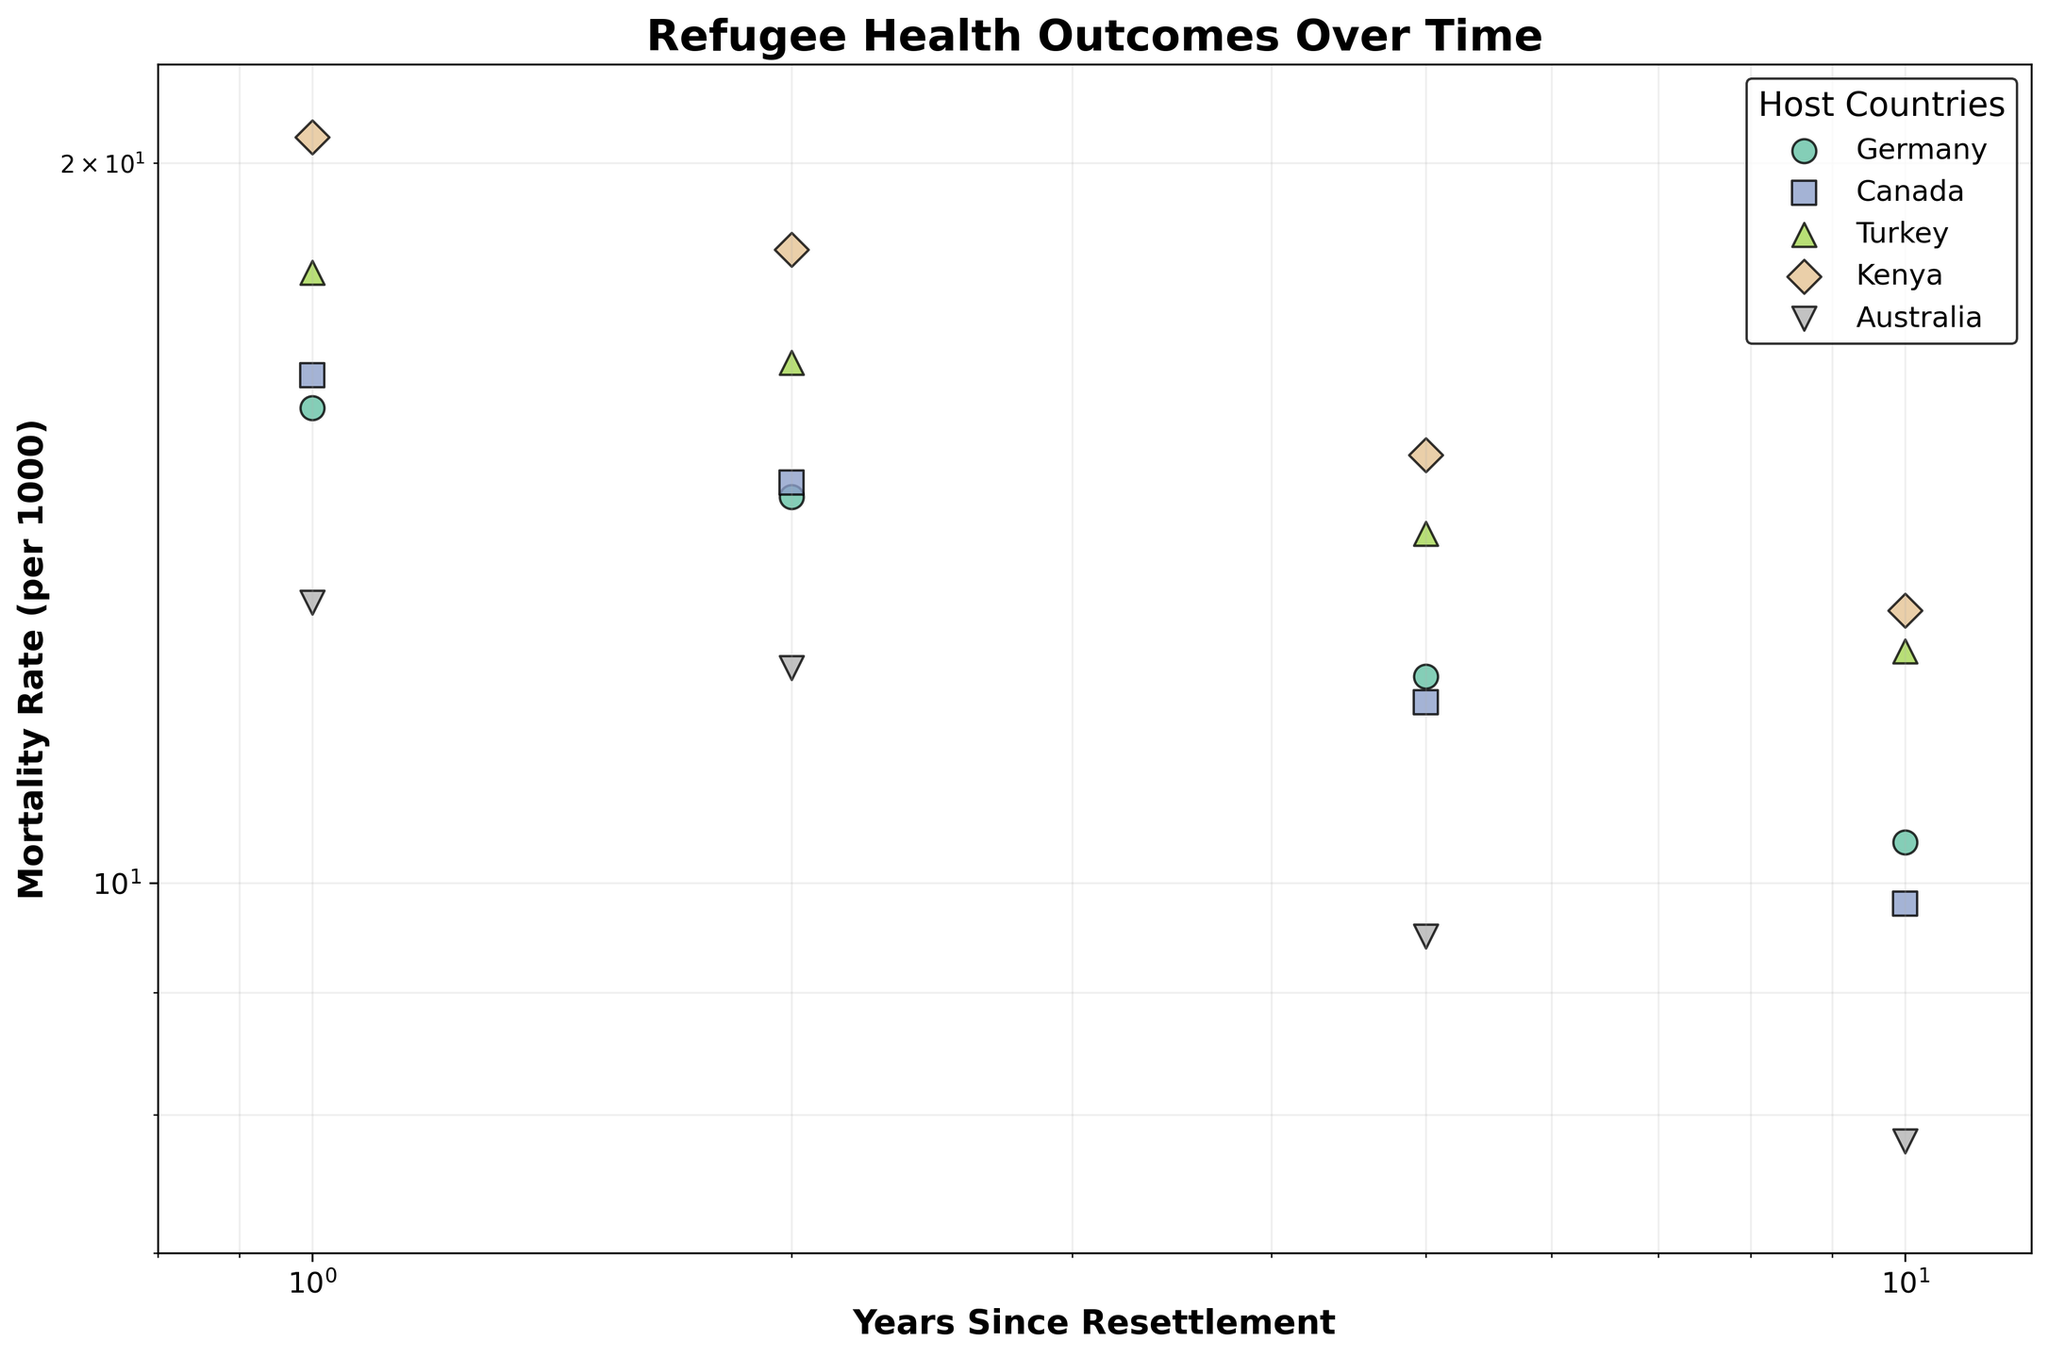What is the title of the plot? The title is usually displayed at the top of the figure. In this case, the title reads 'Refugee Health Outcomes Over Time'.
Answer: Refugee Health Outcomes Over Time Which country has the lowest mortality rate at 10 years since resettlement? By comparing the mortality rates at the 10-year mark for all countries, Australia has the lowest rate of 7.8 per 1000.
Answer: Australia What are the axes' scales in the plot? Both the x and y axes have labels that indicate a logarithmic scale. This is confirmed by the specific ticks and grid lines characteristic of logarithmic scales.
Answer: Logarithmic How do mortality rates change with increasing years since resettlement for refugees in Germany? Observing the scatter plot points for Germany, we see that mortality rates consistently decrease from 15.8 at 1 year to 10.4 at 10 years since resettlement.
Answer: Decrease Which country shows the most significant reduction in mortality rate from 1 year to 10 years since resettlement? Calculating the reduction for each country, Kenya shows a reduction from 20.5 to 13.0, which is a change of 7.5 per 1000, the highest among the countries listed.
Answer: Kenya How does the mortality rate of refugees in Turkey at 1 year since resettlement compare to that in Canada at the same time point? Observing the scatter points at the 1-year mark, Turkey has a mortality rate of 18.0, while Canada has a rate of 16.3 per 1000.
Answer: Turkey's rate is higher What are the marker colors and shapes used for each country in the scatter plot? Each country has a distinct color and marker shape as follows: Germany (light color, circle), Canada (different light color, square), Turkey (another light color, triangle), Kenya (yet another light color, diamond), Australia (a different light color, upside-down triangle). The exact descriptions can be interpreted from the legend.
Answer: Varying light colors and shapes Which host country shows the least change in mortality rate over the 10 years? By evaluating the difference between the 1-year and 10-year data points for each country, Germany has the smallest change, decreasing from 15.8 to 10.4, a difference of 5.4 per 1000.
Answer: Germany If you were to predict the trend beyond 10 years for Australia based on the given data, what would you infer about the mortality rate? Given the decreasing trend from 13.1 at 1 year to 7.8 at 10 years, it is reasonable to infer that the mortality rate would continue to decline beyond 10 years.
Answer: Continue to decline How does the mortality rate trend for the different countries enable us to infer about the overall effectiveness of resettlement policies? By observing the general downward trend in mortality rates for all countries over time, it suggests that resettlement policies may have a positive impact on improving the health outcomes of refugees over the years.
Answer: Positive impact 